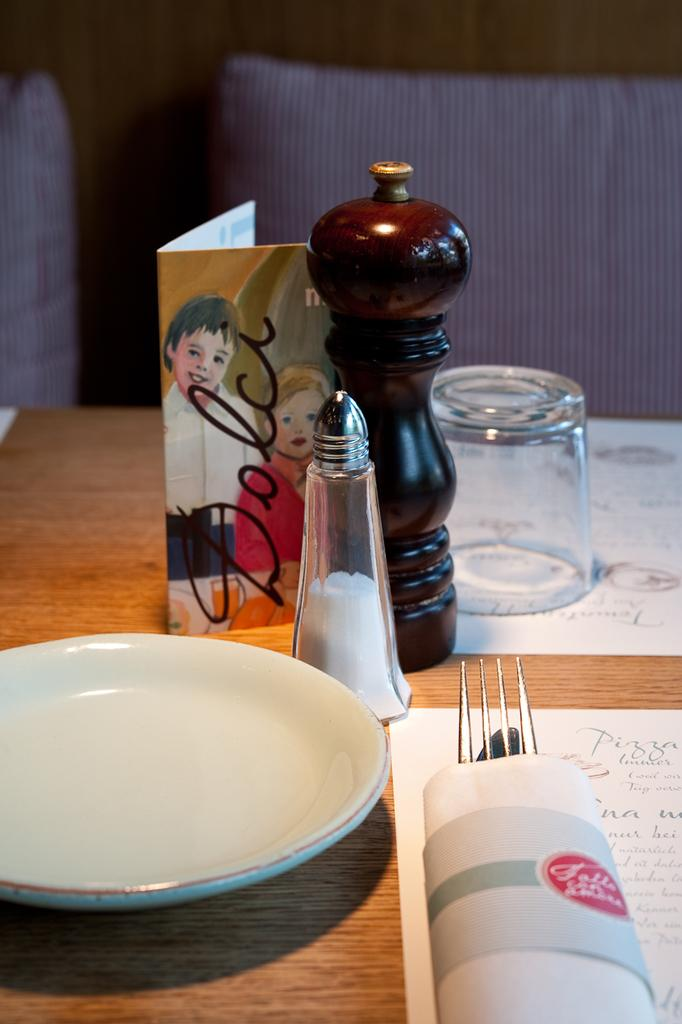What is on the table in the image? There is a glass, a folk, a plate, a cloth, and salt on the table. What might be used for drinking in the image? The glass on the table might be used for drinking. What might be used for eating in the image? The plate on the table might be used for eating. What might be used for seasoning food in the image? The salt on the table might be used for seasoning food. How many trees are visible in the image? There are no trees visible in the image; it features a table with various objects on it. What type of board is being used for the game in the image? There is no board or game present in the image; it only features a table with objects on it. 